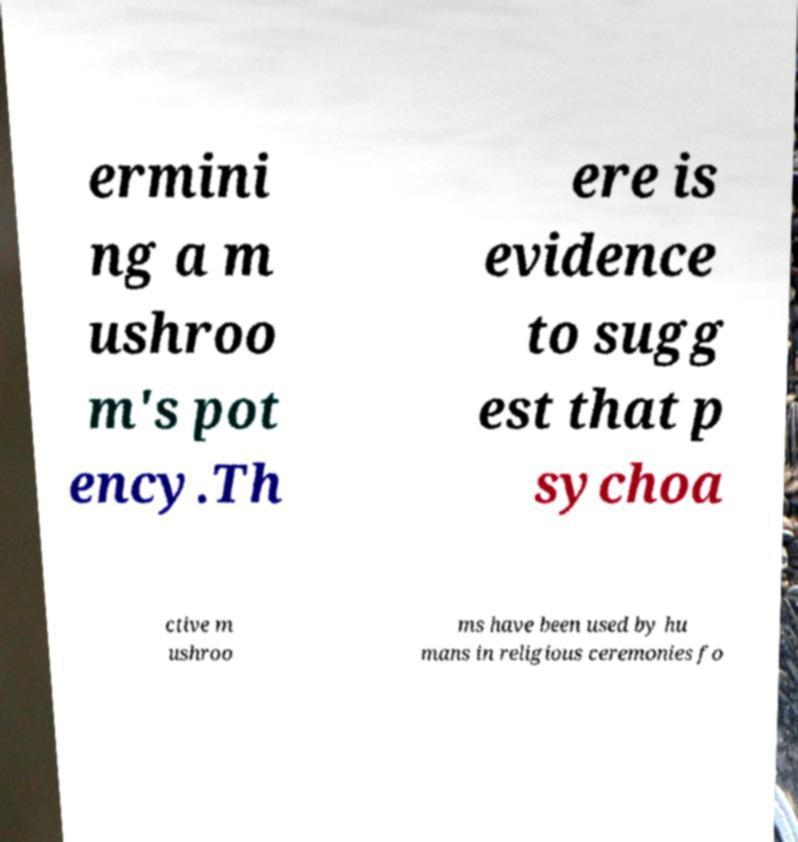For documentation purposes, I need the text within this image transcribed. Could you provide that? ermini ng a m ushroo m's pot ency.Th ere is evidence to sugg est that p sychoa ctive m ushroo ms have been used by hu mans in religious ceremonies fo 